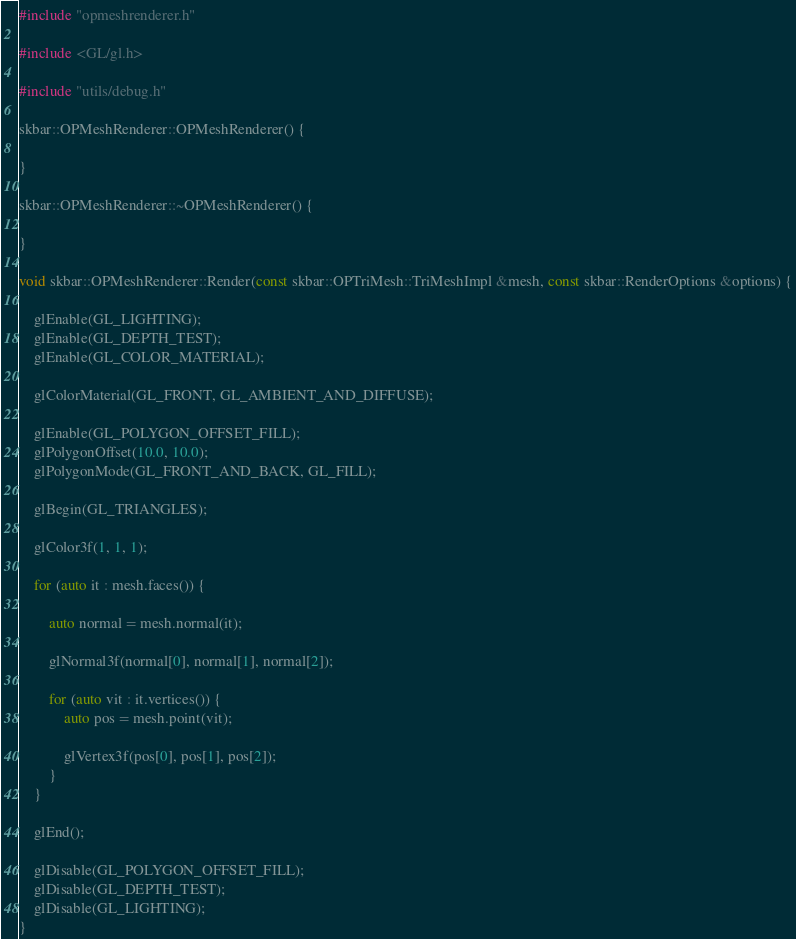<code> <loc_0><loc_0><loc_500><loc_500><_C++_>#include "opmeshrenderer.h"

#include <GL/gl.h>

#include "utils/debug.h"

skbar::OPMeshRenderer::OPMeshRenderer() {

}

skbar::OPMeshRenderer::~OPMeshRenderer() {

}

void skbar::OPMeshRenderer::Render(const skbar::OPTriMesh::TriMeshImpl &mesh, const skbar::RenderOptions &options) {

	glEnable(GL_LIGHTING);
    glEnable(GL_DEPTH_TEST);
	glEnable(GL_COLOR_MATERIAL);

	glColorMaterial(GL_FRONT, GL_AMBIENT_AND_DIFFUSE);

	glEnable(GL_POLYGON_OFFSET_FILL);
	glPolygonOffset(10.0, 10.0);
	glPolygonMode(GL_FRONT_AND_BACK, GL_FILL);

	glBegin(GL_TRIANGLES);

    glColor3f(1, 1, 1);

    for (auto it : mesh.faces()) {

        auto normal = mesh.normal(it);

        glNormal3f(normal[0], normal[1], normal[2]);

        for (auto vit : it.vertices()) {
            auto pos = mesh.point(vit);

            glVertex3f(pos[0], pos[1], pos[2]);
        }
    }

    glEnd();

	glDisable(GL_POLYGON_OFFSET_FILL);
    glDisable(GL_DEPTH_TEST);
	glDisable(GL_LIGHTING);
}

</code> 